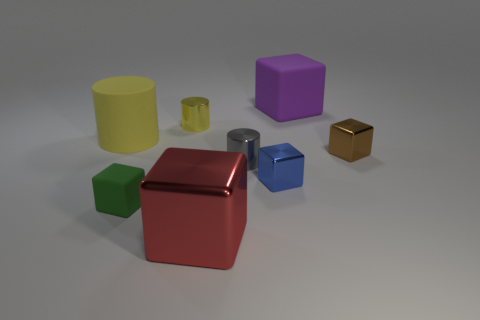How many cyan things are either small rubber things or big rubber cubes?
Your answer should be compact. 0. What number of other things are the same shape as the small brown metallic object?
Give a very brief answer. 4. Is the material of the small yellow object the same as the tiny gray cylinder?
Give a very brief answer. Yes. There is a big object that is both behind the tiny blue block and to the left of the blue object; what is its material?
Provide a succinct answer. Rubber. There is a tiny cube to the left of the large metal block; what is its color?
Provide a short and direct response. Green. Is the number of large metal blocks behind the brown metal thing greater than the number of small gray metal objects?
Keep it short and to the point. No. What number of other objects are the same size as the gray cylinder?
Your response must be concise. 4. There is a tiny green cube; how many small green rubber things are in front of it?
Your answer should be very brief. 0. Are there the same number of small metal blocks in front of the large yellow cylinder and red blocks behind the gray thing?
Offer a terse response. No. The other yellow shiny thing that is the same shape as the big yellow object is what size?
Provide a succinct answer. Small. 